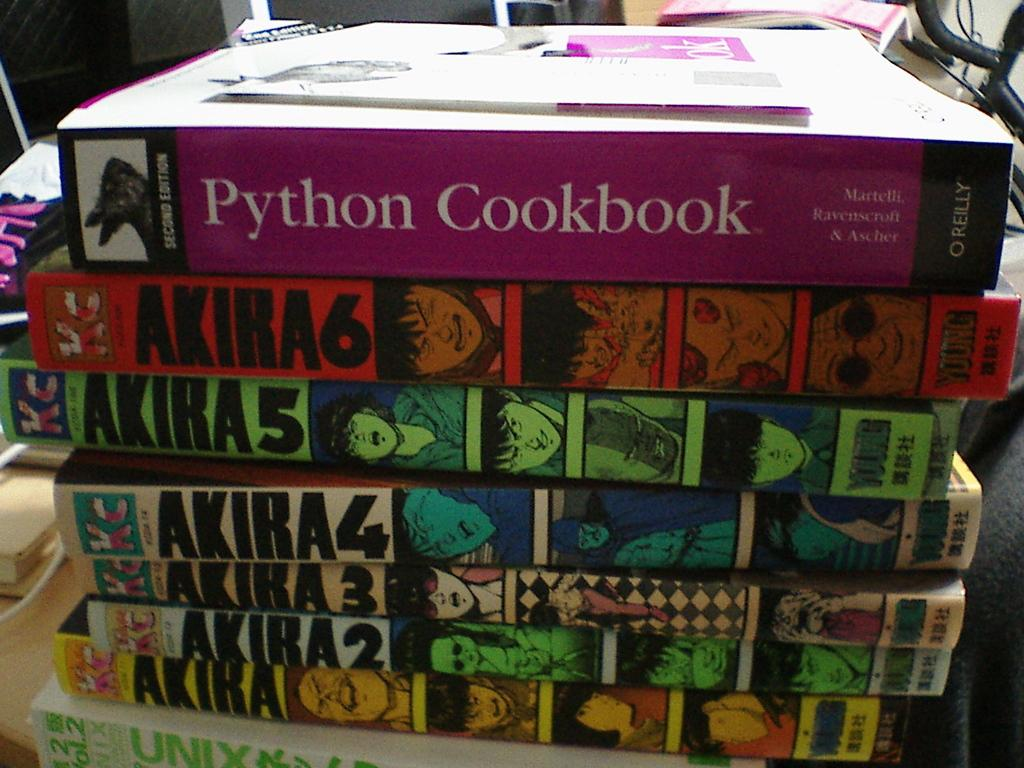Provide a one-sentence caption for the provided image. A stack of books with a cookbook on top. 